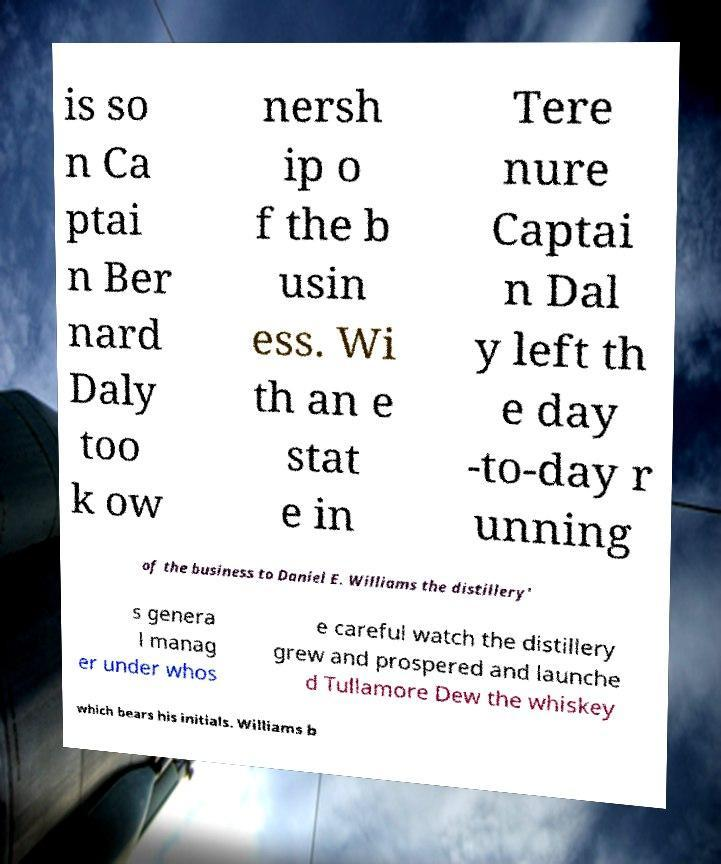Can you accurately transcribe the text from the provided image for me? is so n Ca ptai n Ber nard Daly too k ow nersh ip o f the b usin ess. Wi th an e stat e in Tere nure Captai n Dal y left th e day -to-day r unning of the business to Daniel E. Williams the distillery' s genera l manag er under whos e careful watch the distillery grew and prospered and launche d Tullamore Dew the whiskey which bears his initials. Williams b 